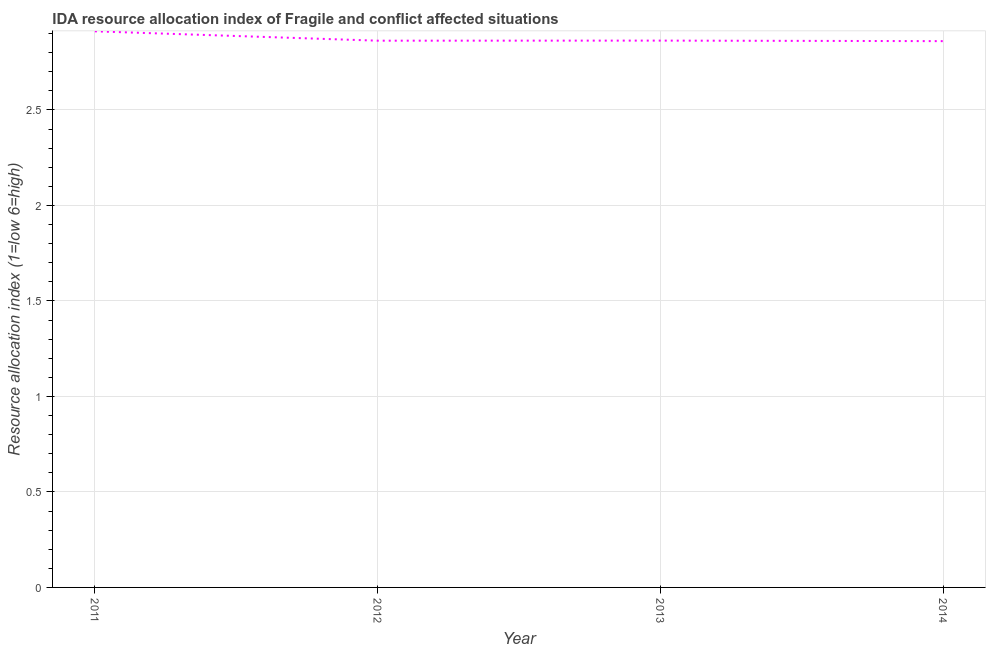What is the ida resource allocation index in 2013?
Offer a terse response. 2.86. Across all years, what is the maximum ida resource allocation index?
Give a very brief answer. 2.91. Across all years, what is the minimum ida resource allocation index?
Your response must be concise. 2.86. What is the sum of the ida resource allocation index?
Keep it short and to the point. 11.5. What is the difference between the ida resource allocation index in 2012 and 2014?
Provide a short and direct response. 0. What is the average ida resource allocation index per year?
Your answer should be very brief. 2.87. What is the median ida resource allocation index?
Ensure brevity in your answer.  2.86. In how many years, is the ida resource allocation index greater than 2.4 ?
Your answer should be very brief. 4. Do a majority of the years between 2012 and 2014 (inclusive) have ida resource allocation index greater than 0.6 ?
Keep it short and to the point. Yes. What is the ratio of the ida resource allocation index in 2011 to that in 2012?
Keep it short and to the point. 1.02. Is the ida resource allocation index in 2012 less than that in 2013?
Give a very brief answer. Yes. Is the difference between the ida resource allocation index in 2011 and 2014 greater than the difference between any two years?
Your answer should be compact. Yes. What is the difference between the highest and the second highest ida resource allocation index?
Ensure brevity in your answer.  0.05. Is the sum of the ida resource allocation index in 2011 and 2014 greater than the maximum ida resource allocation index across all years?
Provide a succinct answer. Yes. What is the difference between the highest and the lowest ida resource allocation index?
Ensure brevity in your answer.  0.05. In how many years, is the ida resource allocation index greater than the average ida resource allocation index taken over all years?
Keep it short and to the point. 1. Does the ida resource allocation index monotonically increase over the years?
Give a very brief answer. No. How many lines are there?
Your answer should be compact. 1. How many years are there in the graph?
Your answer should be very brief. 4. What is the difference between two consecutive major ticks on the Y-axis?
Make the answer very short. 0.5. Are the values on the major ticks of Y-axis written in scientific E-notation?
Your answer should be very brief. No. What is the title of the graph?
Your response must be concise. IDA resource allocation index of Fragile and conflict affected situations. What is the label or title of the Y-axis?
Ensure brevity in your answer.  Resource allocation index (1=low 6=high). What is the Resource allocation index (1=low 6=high) of 2011?
Keep it short and to the point. 2.91. What is the Resource allocation index (1=low 6=high) of 2012?
Offer a terse response. 2.86. What is the Resource allocation index (1=low 6=high) in 2013?
Offer a very short reply. 2.86. What is the Resource allocation index (1=low 6=high) in 2014?
Provide a short and direct response. 2.86. What is the difference between the Resource allocation index (1=low 6=high) in 2011 and 2012?
Your response must be concise. 0.05. What is the difference between the Resource allocation index (1=low 6=high) in 2011 and 2013?
Your answer should be very brief. 0.05. What is the difference between the Resource allocation index (1=low 6=high) in 2011 and 2014?
Give a very brief answer. 0.05. What is the difference between the Resource allocation index (1=low 6=high) in 2012 and 2013?
Make the answer very short. -0. What is the difference between the Resource allocation index (1=low 6=high) in 2012 and 2014?
Ensure brevity in your answer.  0. What is the difference between the Resource allocation index (1=low 6=high) in 2013 and 2014?
Your answer should be compact. 0. What is the ratio of the Resource allocation index (1=low 6=high) in 2011 to that in 2013?
Ensure brevity in your answer.  1.02. What is the ratio of the Resource allocation index (1=low 6=high) in 2011 to that in 2014?
Offer a very short reply. 1.02. What is the ratio of the Resource allocation index (1=low 6=high) in 2012 to that in 2014?
Your response must be concise. 1. What is the ratio of the Resource allocation index (1=low 6=high) in 2013 to that in 2014?
Make the answer very short. 1. 